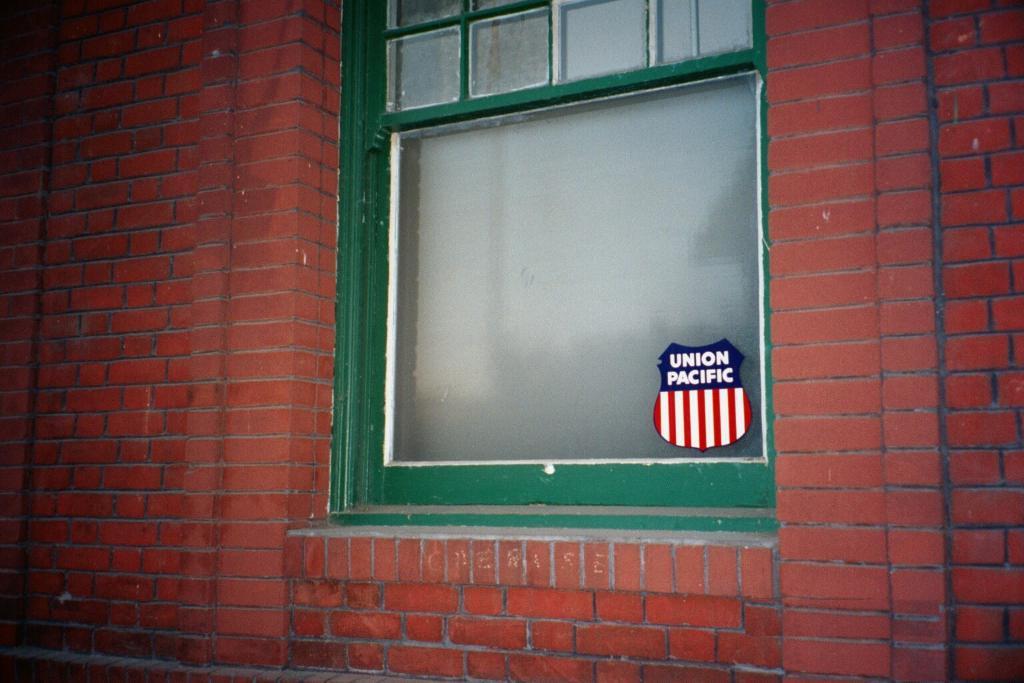What does the sticker say?
Provide a short and direct response. Union pacific. 